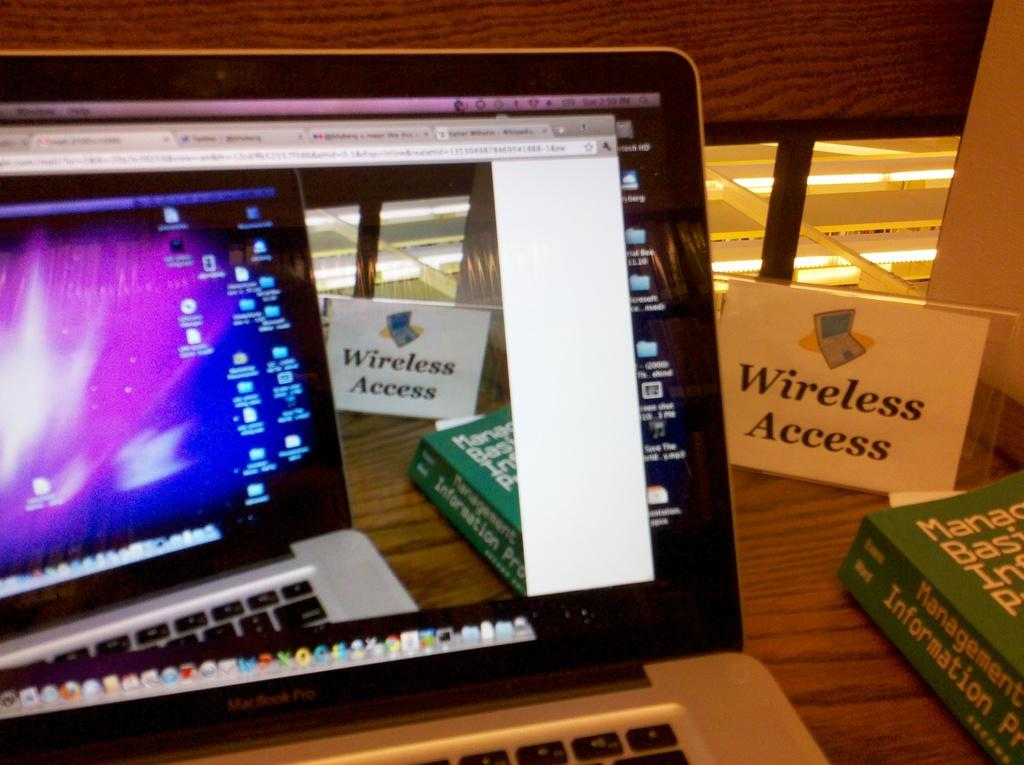<image>
Share a concise interpretation of the image provided. Monitor that has a sign which says "Wireless Access". 